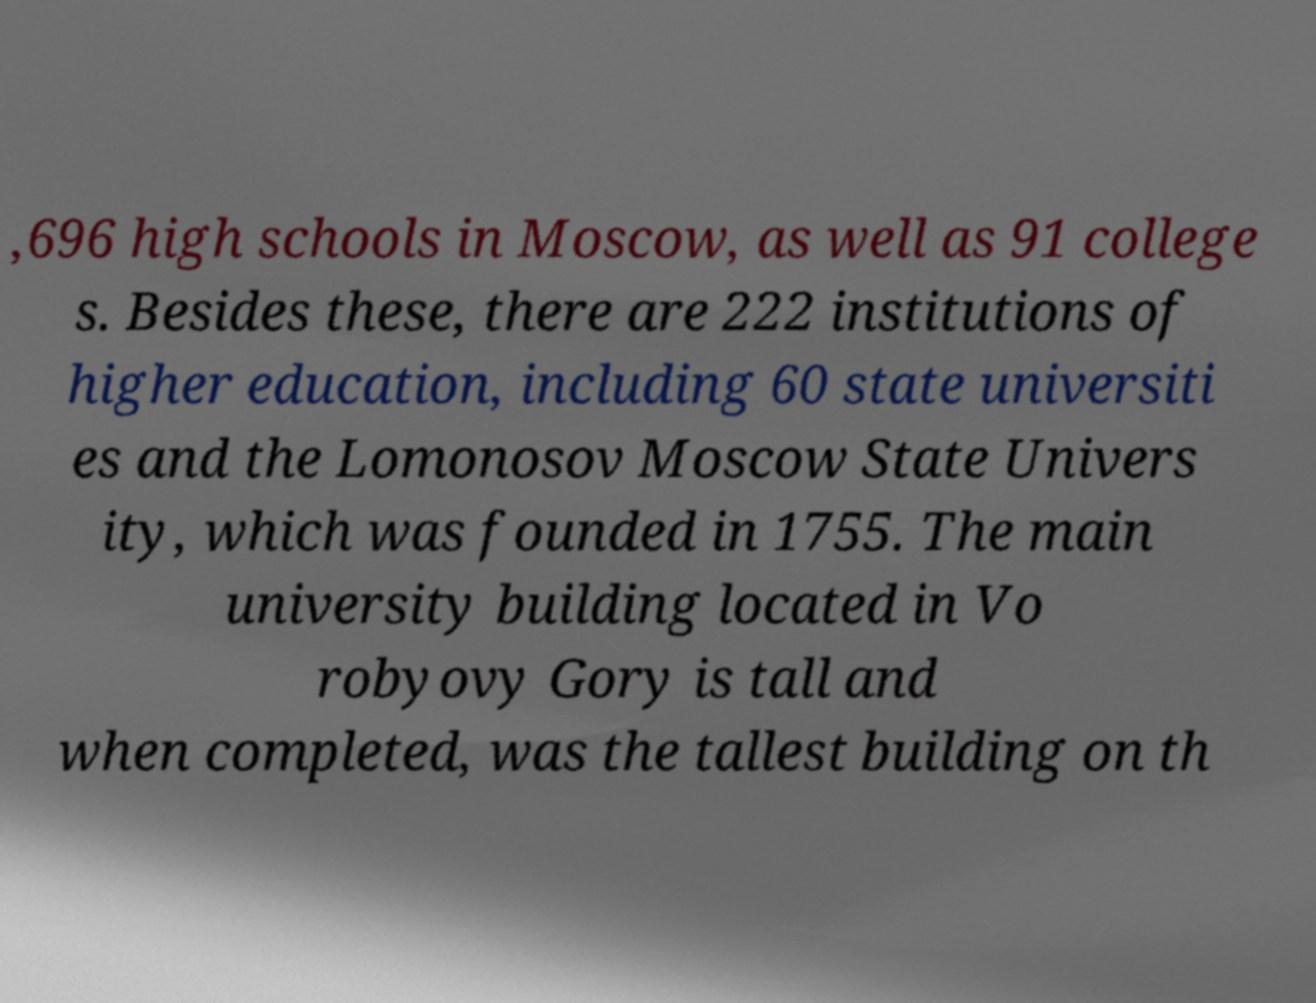Can you accurately transcribe the text from the provided image for me? ,696 high schools in Moscow, as well as 91 college s. Besides these, there are 222 institutions of higher education, including 60 state universiti es and the Lomonosov Moscow State Univers ity, which was founded in 1755. The main university building located in Vo robyovy Gory is tall and when completed, was the tallest building on th 